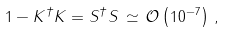Convert formula to latex. <formula><loc_0><loc_0><loc_500><loc_500>1 - K ^ { \dagger } K = S ^ { \dagger } S \, \simeq \, \mathcal { O } \left ( 1 0 ^ { - 7 } \right ) \, ,</formula> 